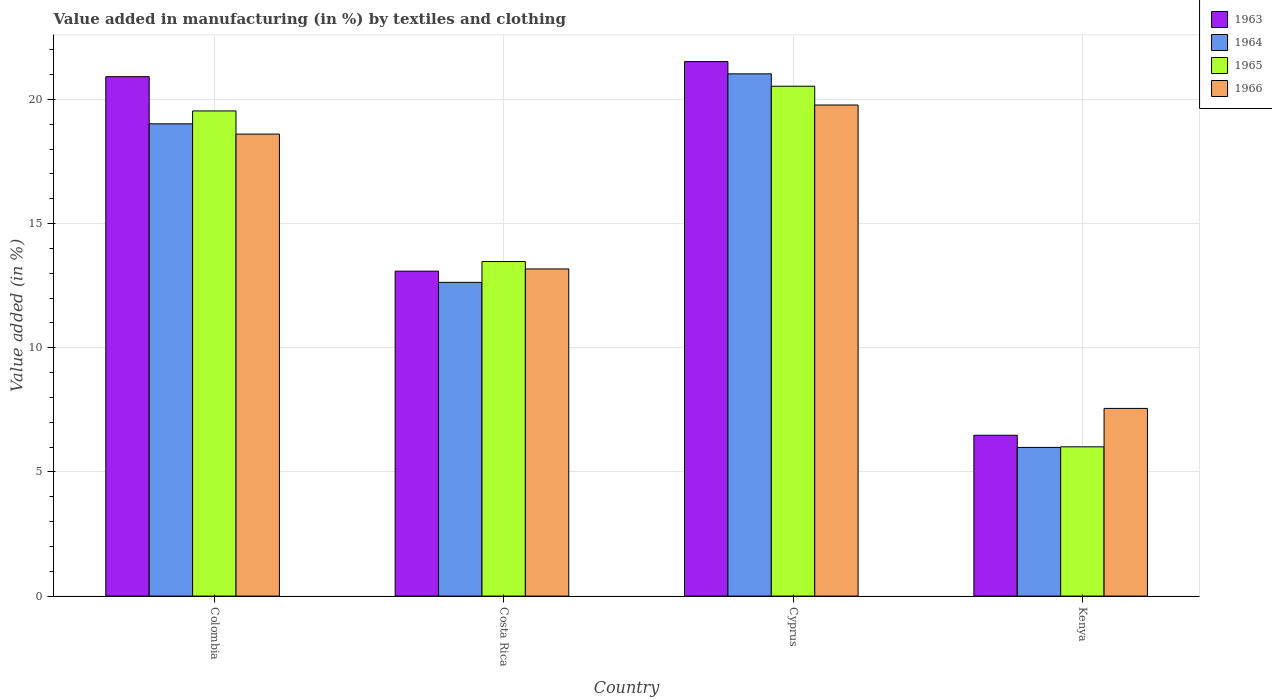How many different coloured bars are there?
Provide a succinct answer. 4. Are the number of bars per tick equal to the number of legend labels?
Ensure brevity in your answer.  Yes. Are the number of bars on each tick of the X-axis equal?
Provide a succinct answer. Yes. How many bars are there on the 2nd tick from the left?
Give a very brief answer. 4. How many bars are there on the 2nd tick from the right?
Offer a terse response. 4. What is the label of the 3rd group of bars from the left?
Your answer should be compact. Cyprus. What is the percentage of value added in manufacturing by textiles and clothing in 1965 in Colombia?
Your answer should be very brief. 19.54. Across all countries, what is the maximum percentage of value added in manufacturing by textiles and clothing in 1966?
Offer a terse response. 19.78. Across all countries, what is the minimum percentage of value added in manufacturing by textiles and clothing in 1966?
Provide a short and direct response. 7.56. In which country was the percentage of value added in manufacturing by textiles and clothing in 1963 maximum?
Offer a terse response. Cyprus. In which country was the percentage of value added in manufacturing by textiles and clothing in 1966 minimum?
Your response must be concise. Kenya. What is the total percentage of value added in manufacturing by textiles and clothing in 1964 in the graph?
Keep it short and to the point. 58.67. What is the difference between the percentage of value added in manufacturing by textiles and clothing in 1964 in Cyprus and that in Kenya?
Keep it short and to the point. 15.04. What is the difference between the percentage of value added in manufacturing by textiles and clothing in 1964 in Cyprus and the percentage of value added in manufacturing by textiles and clothing in 1966 in Colombia?
Your answer should be compact. 2.43. What is the average percentage of value added in manufacturing by textiles and clothing in 1963 per country?
Give a very brief answer. 15.5. What is the difference between the percentage of value added in manufacturing by textiles and clothing of/in 1965 and percentage of value added in manufacturing by textiles and clothing of/in 1966 in Cyprus?
Your answer should be very brief. 0.76. What is the ratio of the percentage of value added in manufacturing by textiles and clothing in 1964 in Costa Rica to that in Cyprus?
Provide a short and direct response. 0.6. Is the difference between the percentage of value added in manufacturing by textiles and clothing in 1965 in Colombia and Cyprus greater than the difference between the percentage of value added in manufacturing by textiles and clothing in 1966 in Colombia and Cyprus?
Keep it short and to the point. Yes. What is the difference between the highest and the second highest percentage of value added in manufacturing by textiles and clothing in 1963?
Keep it short and to the point. -7.83. What is the difference between the highest and the lowest percentage of value added in manufacturing by textiles and clothing in 1966?
Your answer should be very brief. 12.22. Is the sum of the percentage of value added in manufacturing by textiles and clothing in 1964 in Colombia and Costa Rica greater than the maximum percentage of value added in manufacturing by textiles and clothing in 1965 across all countries?
Your answer should be compact. Yes. What does the 4th bar from the left in Colombia represents?
Offer a terse response. 1966. What does the 3rd bar from the right in Kenya represents?
Keep it short and to the point. 1964. Is it the case that in every country, the sum of the percentage of value added in manufacturing by textiles and clothing in 1963 and percentage of value added in manufacturing by textiles and clothing in 1966 is greater than the percentage of value added in manufacturing by textiles and clothing in 1965?
Your answer should be very brief. Yes. How many countries are there in the graph?
Your answer should be very brief. 4. What is the difference between two consecutive major ticks on the Y-axis?
Offer a very short reply. 5. Does the graph contain any zero values?
Make the answer very short. No. Does the graph contain grids?
Ensure brevity in your answer.  Yes. Where does the legend appear in the graph?
Provide a short and direct response. Top right. How many legend labels are there?
Give a very brief answer. 4. How are the legend labels stacked?
Keep it short and to the point. Vertical. What is the title of the graph?
Offer a terse response. Value added in manufacturing (in %) by textiles and clothing. Does "1961" appear as one of the legend labels in the graph?
Make the answer very short. No. What is the label or title of the X-axis?
Your response must be concise. Country. What is the label or title of the Y-axis?
Your response must be concise. Value added (in %). What is the Value added (in %) in 1963 in Colombia?
Your response must be concise. 20.92. What is the Value added (in %) in 1964 in Colombia?
Your response must be concise. 19.02. What is the Value added (in %) of 1965 in Colombia?
Your response must be concise. 19.54. What is the Value added (in %) in 1966 in Colombia?
Provide a succinct answer. 18.6. What is the Value added (in %) of 1963 in Costa Rica?
Your answer should be very brief. 13.08. What is the Value added (in %) of 1964 in Costa Rica?
Offer a terse response. 12.63. What is the Value added (in %) in 1965 in Costa Rica?
Offer a terse response. 13.47. What is the Value added (in %) in 1966 in Costa Rica?
Ensure brevity in your answer.  13.17. What is the Value added (in %) of 1963 in Cyprus?
Keep it short and to the point. 21.52. What is the Value added (in %) in 1964 in Cyprus?
Offer a terse response. 21.03. What is the Value added (in %) of 1965 in Cyprus?
Provide a short and direct response. 20.53. What is the Value added (in %) in 1966 in Cyprus?
Make the answer very short. 19.78. What is the Value added (in %) in 1963 in Kenya?
Offer a terse response. 6.48. What is the Value added (in %) in 1964 in Kenya?
Provide a short and direct response. 5.99. What is the Value added (in %) in 1965 in Kenya?
Give a very brief answer. 6.01. What is the Value added (in %) in 1966 in Kenya?
Your answer should be compact. 7.56. Across all countries, what is the maximum Value added (in %) of 1963?
Provide a succinct answer. 21.52. Across all countries, what is the maximum Value added (in %) of 1964?
Your response must be concise. 21.03. Across all countries, what is the maximum Value added (in %) of 1965?
Provide a succinct answer. 20.53. Across all countries, what is the maximum Value added (in %) in 1966?
Make the answer very short. 19.78. Across all countries, what is the minimum Value added (in %) in 1963?
Your answer should be very brief. 6.48. Across all countries, what is the minimum Value added (in %) in 1964?
Ensure brevity in your answer.  5.99. Across all countries, what is the minimum Value added (in %) of 1965?
Your answer should be compact. 6.01. Across all countries, what is the minimum Value added (in %) in 1966?
Your response must be concise. 7.56. What is the total Value added (in %) in 1963 in the graph?
Your answer should be compact. 62. What is the total Value added (in %) of 1964 in the graph?
Keep it short and to the point. 58.67. What is the total Value added (in %) in 1965 in the graph?
Give a very brief answer. 59.55. What is the total Value added (in %) of 1966 in the graph?
Make the answer very short. 59.11. What is the difference between the Value added (in %) in 1963 in Colombia and that in Costa Rica?
Your answer should be compact. 7.83. What is the difference between the Value added (in %) of 1964 in Colombia and that in Costa Rica?
Your response must be concise. 6.38. What is the difference between the Value added (in %) of 1965 in Colombia and that in Costa Rica?
Provide a succinct answer. 6.06. What is the difference between the Value added (in %) of 1966 in Colombia and that in Costa Rica?
Offer a very short reply. 5.43. What is the difference between the Value added (in %) in 1963 in Colombia and that in Cyprus?
Ensure brevity in your answer.  -0.61. What is the difference between the Value added (in %) of 1964 in Colombia and that in Cyprus?
Offer a very short reply. -2.01. What is the difference between the Value added (in %) of 1965 in Colombia and that in Cyprus?
Your answer should be very brief. -0.99. What is the difference between the Value added (in %) of 1966 in Colombia and that in Cyprus?
Keep it short and to the point. -1.17. What is the difference between the Value added (in %) of 1963 in Colombia and that in Kenya?
Ensure brevity in your answer.  14.44. What is the difference between the Value added (in %) in 1964 in Colombia and that in Kenya?
Offer a terse response. 13.03. What is the difference between the Value added (in %) in 1965 in Colombia and that in Kenya?
Offer a terse response. 13.53. What is the difference between the Value added (in %) of 1966 in Colombia and that in Kenya?
Offer a very short reply. 11.05. What is the difference between the Value added (in %) of 1963 in Costa Rica and that in Cyprus?
Offer a terse response. -8.44. What is the difference between the Value added (in %) in 1964 in Costa Rica and that in Cyprus?
Keep it short and to the point. -8.4. What is the difference between the Value added (in %) in 1965 in Costa Rica and that in Cyprus?
Your answer should be very brief. -7.06. What is the difference between the Value added (in %) in 1966 in Costa Rica and that in Cyprus?
Your answer should be compact. -6.6. What is the difference between the Value added (in %) in 1963 in Costa Rica and that in Kenya?
Your response must be concise. 6.61. What is the difference between the Value added (in %) of 1964 in Costa Rica and that in Kenya?
Make the answer very short. 6.65. What is the difference between the Value added (in %) of 1965 in Costa Rica and that in Kenya?
Keep it short and to the point. 7.46. What is the difference between the Value added (in %) of 1966 in Costa Rica and that in Kenya?
Offer a very short reply. 5.62. What is the difference between the Value added (in %) in 1963 in Cyprus and that in Kenya?
Your response must be concise. 15.05. What is the difference between the Value added (in %) in 1964 in Cyprus and that in Kenya?
Your answer should be very brief. 15.04. What is the difference between the Value added (in %) of 1965 in Cyprus and that in Kenya?
Keep it short and to the point. 14.52. What is the difference between the Value added (in %) in 1966 in Cyprus and that in Kenya?
Your answer should be compact. 12.22. What is the difference between the Value added (in %) of 1963 in Colombia and the Value added (in %) of 1964 in Costa Rica?
Ensure brevity in your answer.  8.28. What is the difference between the Value added (in %) of 1963 in Colombia and the Value added (in %) of 1965 in Costa Rica?
Offer a very short reply. 7.44. What is the difference between the Value added (in %) of 1963 in Colombia and the Value added (in %) of 1966 in Costa Rica?
Your response must be concise. 7.74. What is the difference between the Value added (in %) of 1964 in Colombia and the Value added (in %) of 1965 in Costa Rica?
Your answer should be compact. 5.55. What is the difference between the Value added (in %) of 1964 in Colombia and the Value added (in %) of 1966 in Costa Rica?
Give a very brief answer. 5.84. What is the difference between the Value added (in %) of 1965 in Colombia and the Value added (in %) of 1966 in Costa Rica?
Ensure brevity in your answer.  6.36. What is the difference between the Value added (in %) in 1963 in Colombia and the Value added (in %) in 1964 in Cyprus?
Make the answer very short. -0.11. What is the difference between the Value added (in %) of 1963 in Colombia and the Value added (in %) of 1965 in Cyprus?
Your answer should be very brief. 0.39. What is the difference between the Value added (in %) of 1963 in Colombia and the Value added (in %) of 1966 in Cyprus?
Your response must be concise. 1.14. What is the difference between the Value added (in %) of 1964 in Colombia and the Value added (in %) of 1965 in Cyprus?
Make the answer very short. -1.51. What is the difference between the Value added (in %) of 1964 in Colombia and the Value added (in %) of 1966 in Cyprus?
Offer a very short reply. -0.76. What is the difference between the Value added (in %) of 1965 in Colombia and the Value added (in %) of 1966 in Cyprus?
Give a very brief answer. -0.24. What is the difference between the Value added (in %) of 1963 in Colombia and the Value added (in %) of 1964 in Kenya?
Ensure brevity in your answer.  14.93. What is the difference between the Value added (in %) of 1963 in Colombia and the Value added (in %) of 1965 in Kenya?
Give a very brief answer. 14.91. What is the difference between the Value added (in %) in 1963 in Colombia and the Value added (in %) in 1966 in Kenya?
Provide a short and direct response. 13.36. What is the difference between the Value added (in %) in 1964 in Colombia and the Value added (in %) in 1965 in Kenya?
Provide a succinct answer. 13.01. What is the difference between the Value added (in %) in 1964 in Colombia and the Value added (in %) in 1966 in Kenya?
Offer a very short reply. 11.46. What is the difference between the Value added (in %) in 1965 in Colombia and the Value added (in %) in 1966 in Kenya?
Provide a succinct answer. 11.98. What is the difference between the Value added (in %) of 1963 in Costa Rica and the Value added (in %) of 1964 in Cyprus?
Ensure brevity in your answer.  -7.95. What is the difference between the Value added (in %) of 1963 in Costa Rica and the Value added (in %) of 1965 in Cyprus?
Offer a very short reply. -7.45. What is the difference between the Value added (in %) of 1963 in Costa Rica and the Value added (in %) of 1966 in Cyprus?
Your answer should be compact. -6.69. What is the difference between the Value added (in %) of 1964 in Costa Rica and the Value added (in %) of 1965 in Cyprus?
Ensure brevity in your answer.  -7.9. What is the difference between the Value added (in %) in 1964 in Costa Rica and the Value added (in %) in 1966 in Cyprus?
Keep it short and to the point. -7.14. What is the difference between the Value added (in %) of 1965 in Costa Rica and the Value added (in %) of 1966 in Cyprus?
Provide a short and direct response. -6.3. What is the difference between the Value added (in %) in 1963 in Costa Rica and the Value added (in %) in 1964 in Kenya?
Make the answer very short. 7.1. What is the difference between the Value added (in %) of 1963 in Costa Rica and the Value added (in %) of 1965 in Kenya?
Your answer should be very brief. 7.07. What is the difference between the Value added (in %) in 1963 in Costa Rica and the Value added (in %) in 1966 in Kenya?
Give a very brief answer. 5.53. What is the difference between the Value added (in %) of 1964 in Costa Rica and the Value added (in %) of 1965 in Kenya?
Your answer should be very brief. 6.62. What is the difference between the Value added (in %) in 1964 in Costa Rica and the Value added (in %) in 1966 in Kenya?
Your answer should be compact. 5.08. What is the difference between the Value added (in %) of 1965 in Costa Rica and the Value added (in %) of 1966 in Kenya?
Offer a terse response. 5.91. What is the difference between the Value added (in %) of 1963 in Cyprus and the Value added (in %) of 1964 in Kenya?
Your response must be concise. 15.54. What is the difference between the Value added (in %) in 1963 in Cyprus and the Value added (in %) in 1965 in Kenya?
Provide a succinct answer. 15.51. What is the difference between the Value added (in %) of 1963 in Cyprus and the Value added (in %) of 1966 in Kenya?
Give a very brief answer. 13.97. What is the difference between the Value added (in %) in 1964 in Cyprus and the Value added (in %) in 1965 in Kenya?
Offer a terse response. 15.02. What is the difference between the Value added (in %) in 1964 in Cyprus and the Value added (in %) in 1966 in Kenya?
Make the answer very short. 13.47. What is the difference between the Value added (in %) of 1965 in Cyprus and the Value added (in %) of 1966 in Kenya?
Your answer should be compact. 12.97. What is the average Value added (in %) of 1963 per country?
Provide a succinct answer. 15.5. What is the average Value added (in %) of 1964 per country?
Your answer should be compact. 14.67. What is the average Value added (in %) of 1965 per country?
Your answer should be very brief. 14.89. What is the average Value added (in %) in 1966 per country?
Make the answer very short. 14.78. What is the difference between the Value added (in %) of 1963 and Value added (in %) of 1964 in Colombia?
Ensure brevity in your answer.  1.9. What is the difference between the Value added (in %) of 1963 and Value added (in %) of 1965 in Colombia?
Offer a terse response. 1.38. What is the difference between the Value added (in %) in 1963 and Value added (in %) in 1966 in Colombia?
Provide a succinct answer. 2.31. What is the difference between the Value added (in %) in 1964 and Value added (in %) in 1965 in Colombia?
Keep it short and to the point. -0.52. What is the difference between the Value added (in %) in 1964 and Value added (in %) in 1966 in Colombia?
Offer a very short reply. 0.41. What is the difference between the Value added (in %) of 1965 and Value added (in %) of 1966 in Colombia?
Make the answer very short. 0.93. What is the difference between the Value added (in %) of 1963 and Value added (in %) of 1964 in Costa Rica?
Ensure brevity in your answer.  0.45. What is the difference between the Value added (in %) in 1963 and Value added (in %) in 1965 in Costa Rica?
Provide a short and direct response. -0.39. What is the difference between the Value added (in %) in 1963 and Value added (in %) in 1966 in Costa Rica?
Offer a terse response. -0.09. What is the difference between the Value added (in %) of 1964 and Value added (in %) of 1965 in Costa Rica?
Offer a terse response. -0.84. What is the difference between the Value added (in %) in 1964 and Value added (in %) in 1966 in Costa Rica?
Provide a succinct answer. -0.54. What is the difference between the Value added (in %) of 1965 and Value added (in %) of 1966 in Costa Rica?
Ensure brevity in your answer.  0.3. What is the difference between the Value added (in %) of 1963 and Value added (in %) of 1964 in Cyprus?
Keep it short and to the point. 0.49. What is the difference between the Value added (in %) of 1963 and Value added (in %) of 1966 in Cyprus?
Your answer should be very brief. 1.75. What is the difference between the Value added (in %) of 1964 and Value added (in %) of 1965 in Cyprus?
Your response must be concise. 0.5. What is the difference between the Value added (in %) of 1964 and Value added (in %) of 1966 in Cyprus?
Your answer should be compact. 1.25. What is the difference between the Value added (in %) of 1965 and Value added (in %) of 1966 in Cyprus?
Your response must be concise. 0.76. What is the difference between the Value added (in %) of 1963 and Value added (in %) of 1964 in Kenya?
Offer a very short reply. 0.49. What is the difference between the Value added (in %) in 1963 and Value added (in %) in 1965 in Kenya?
Give a very brief answer. 0.47. What is the difference between the Value added (in %) in 1963 and Value added (in %) in 1966 in Kenya?
Make the answer very short. -1.08. What is the difference between the Value added (in %) in 1964 and Value added (in %) in 1965 in Kenya?
Your answer should be very brief. -0.02. What is the difference between the Value added (in %) of 1964 and Value added (in %) of 1966 in Kenya?
Provide a short and direct response. -1.57. What is the difference between the Value added (in %) in 1965 and Value added (in %) in 1966 in Kenya?
Keep it short and to the point. -1.55. What is the ratio of the Value added (in %) in 1963 in Colombia to that in Costa Rica?
Provide a short and direct response. 1.6. What is the ratio of the Value added (in %) in 1964 in Colombia to that in Costa Rica?
Your answer should be compact. 1.51. What is the ratio of the Value added (in %) of 1965 in Colombia to that in Costa Rica?
Ensure brevity in your answer.  1.45. What is the ratio of the Value added (in %) of 1966 in Colombia to that in Costa Rica?
Your response must be concise. 1.41. What is the ratio of the Value added (in %) in 1963 in Colombia to that in Cyprus?
Ensure brevity in your answer.  0.97. What is the ratio of the Value added (in %) in 1964 in Colombia to that in Cyprus?
Make the answer very short. 0.9. What is the ratio of the Value added (in %) of 1965 in Colombia to that in Cyprus?
Your response must be concise. 0.95. What is the ratio of the Value added (in %) of 1966 in Colombia to that in Cyprus?
Offer a terse response. 0.94. What is the ratio of the Value added (in %) in 1963 in Colombia to that in Kenya?
Keep it short and to the point. 3.23. What is the ratio of the Value added (in %) of 1964 in Colombia to that in Kenya?
Give a very brief answer. 3.18. What is the ratio of the Value added (in %) of 1965 in Colombia to that in Kenya?
Ensure brevity in your answer.  3.25. What is the ratio of the Value added (in %) in 1966 in Colombia to that in Kenya?
Keep it short and to the point. 2.46. What is the ratio of the Value added (in %) in 1963 in Costa Rica to that in Cyprus?
Give a very brief answer. 0.61. What is the ratio of the Value added (in %) in 1964 in Costa Rica to that in Cyprus?
Your answer should be very brief. 0.6. What is the ratio of the Value added (in %) of 1965 in Costa Rica to that in Cyprus?
Provide a succinct answer. 0.66. What is the ratio of the Value added (in %) in 1966 in Costa Rica to that in Cyprus?
Make the answer very short. 0.67. What is the ratio of the Value added (in %) in 1963 in Costa Rica to that in Kenya?
Offer a very short reply. 2.02. What is the ratio of the Value added (in %) in 1964 in Costa Rica to that in Kenya?
Give a very brief answer. 2.11. What is the ratio of the Value added (in %) of 1965 in Costa Rica to that in Kenya?
Your answer should be compact. 2.24. What is the ratio of the Value added (in %) in 1966 in Costa Rica to that in Kenya?
Make the answer very short. 1.74. What is the ratio of the Value added (in %) in 1963 in Cyprus to that in Kenya?
Offer a terse response. 3.32. What is the ratio of the Value added (in %) in 1964 in Cyprus to that in Kenya?
Offer a terse response. 3.51. What is the ratio of the Value added (in %) of 1965 in Cyprus to that in Kenya?
Your answer should be compact. 3.42. What is the ratio of the Value added (in %) of 1966 in Cyprus to that in Kenya?
Keep it short and to the point. 2.62. What is the difference between the highest and the second highest Value added (in %) in 1963?
Keep it short and to the point. 0.61. What is the difference between the highest and the second highest Value added (in %) in 1964?
Your response must be concise. 2.01. What is the difference between the highest and the second highest Value added (in %) of 1966?
Give a very brief answer. 1.17. What is the difference between the highest and the lowest Value added (in %) of 1963?
Your answer should be compact. 15.05. What is the difference between the highest and the lowest Value added (in %) of 1964?
Provide a succinct answer. 15.04. What is the difference between the highest and the lowest Value added (in %) of 1965?
Provide a succinct answer. 14.52. What is the difference between the highest and the lowest Value added (in %) of 1966?
Your answer should be compact. 12.22. 